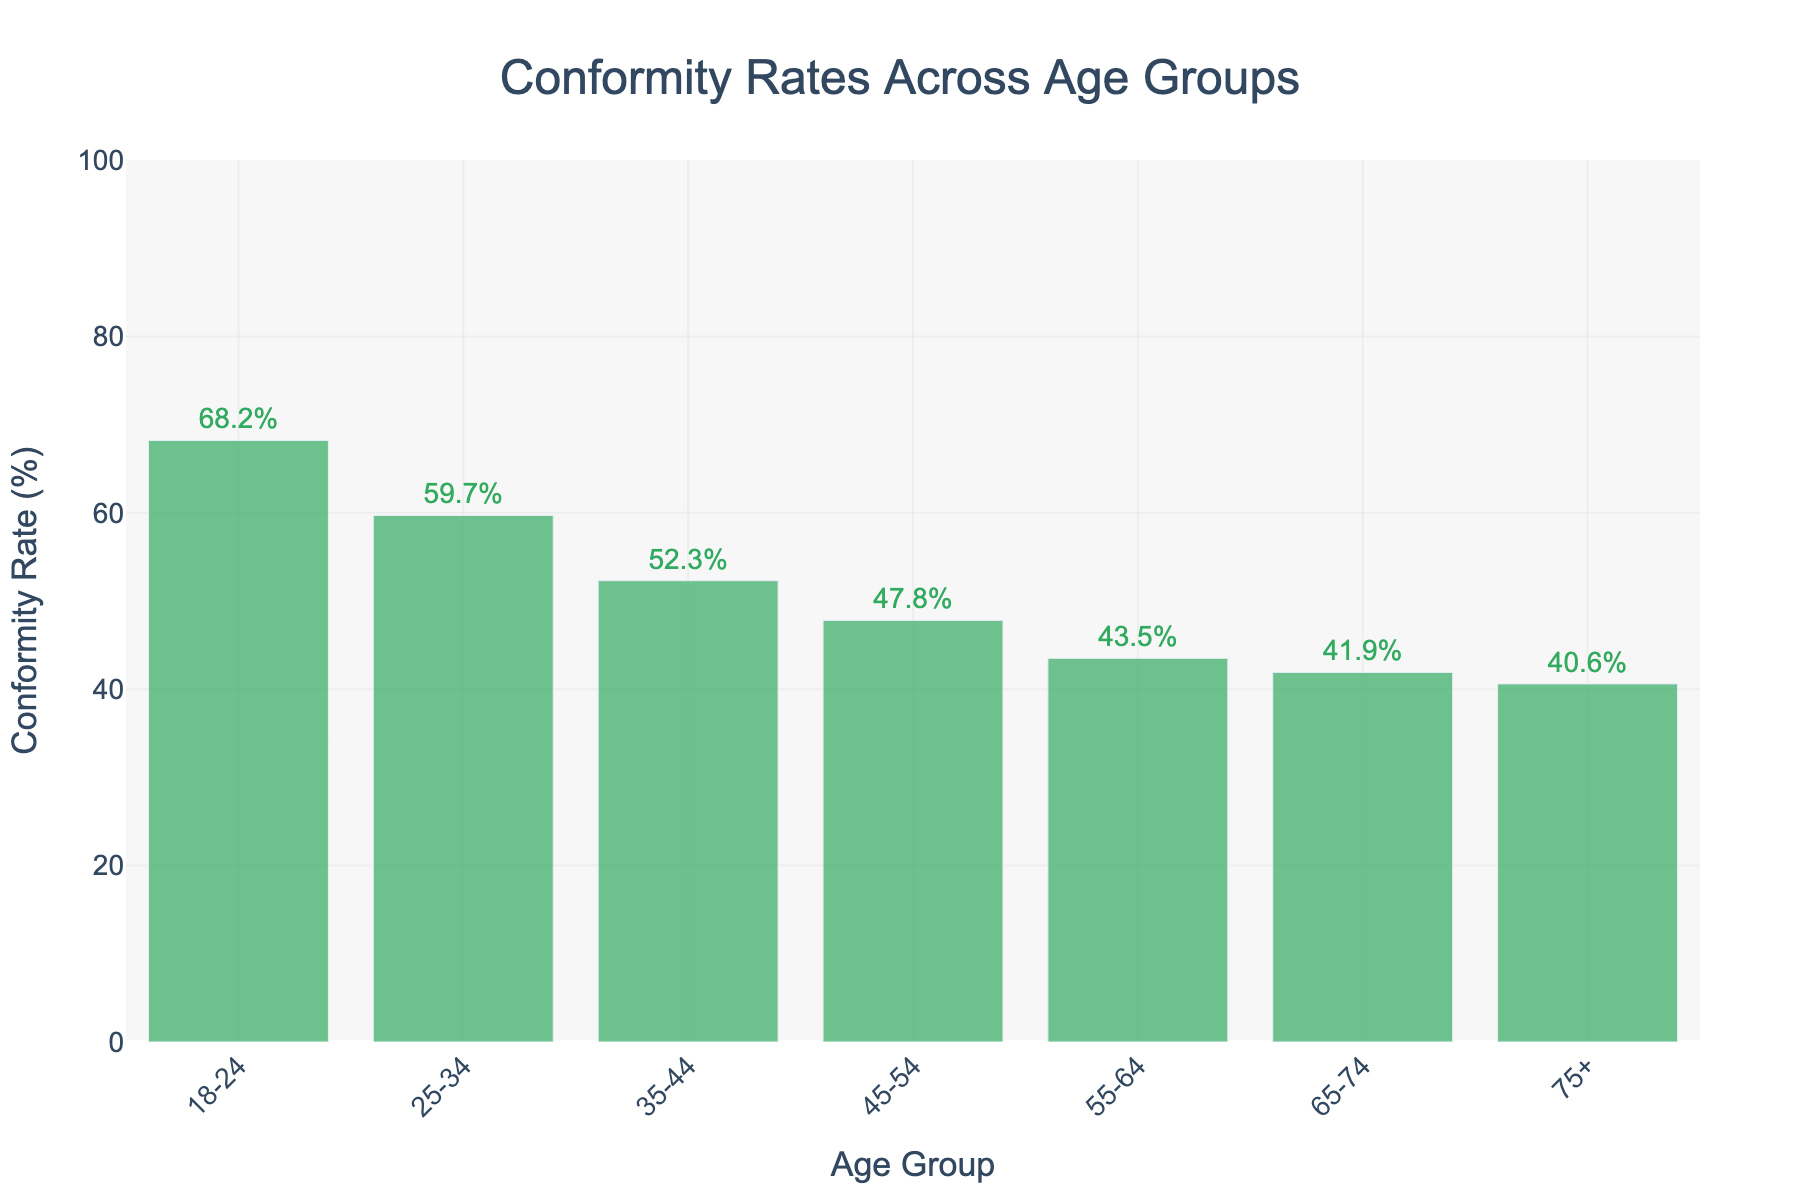What age group has the highest conformity rate? The figure shows bars representing different age groups, with their heights indicating the conformity rate. The tallest bar corresponds to the 18-24 age group.
Answer: 18-24 Which age group has the lowest conformity rate? By looking at the bar heights, the shortest bar represents the 75+ age group, indicating the lowest conformity rate.
Answer: 75+ What is the conformity rate difference between the 18-24 and 75+ age groups? The conformity rate for the 18-24 age group is 68.2%, and for the 75+ group, it is 40.6%. Subtracting 40.6 from 68.2 gives the difference. 68.2% - 40.6% = 27.6%
Answer: 27.6% Is the conformity rate for the age group 35-44 more or less than 50%? The bar for the 35-44 age group is labeled 52.3%, which is greater than 50%.
Answer: More In which age group(s) does the conformity rate fall below 50%? By observing the heights of the bars, we see that the age groups 45-54, 55-64, 65-74, and 75+ have conformity rates below 50%.
Answer: 45-54, 55-64, 65-74, 75+ What is the total conformity rate for all age groups combined? Sum the conformity rates for all age groups: 68.2 + 59.7 + 52.3 + 47.8 + 43.5 + 41.9 + 40.6 = 354
Answer: 354% How many age groups have a conformity rate of more than 45%? Count the number of bars with heights greater than 45%. The age groups 18-24, 25-34, 35-44, and 45-54 meet this criterion.
Answer: 4 Is the conformity rate for age group 25-34 closer to that of age group 35-44 or 45-54? We compare the differences:
Answer: 35-44: abs(59.7-52.3)=7.4, 45-54: abs(59.7-47.8)=11.9. Since 7.4 < 11.9, 25-34 is closer to 35-44 Rank the age groups from highest to lowest conformity rate. By visually comparing and ranking the heights of the bars, we get: 18-24 > 25-34 > 35-44 > 45-54 > 55-64 > 65-74 > 75+
Answer: 18-24, 25-34, 35-44, 45-54, 55-64, 65-74, 75+ Does the conformity rate decline uniformly across consecutive age groups? Observing the bar heights, we see that the rate consistently declines from 18-24 to 75+, indicating a uniform trend.
Answer: Yes 